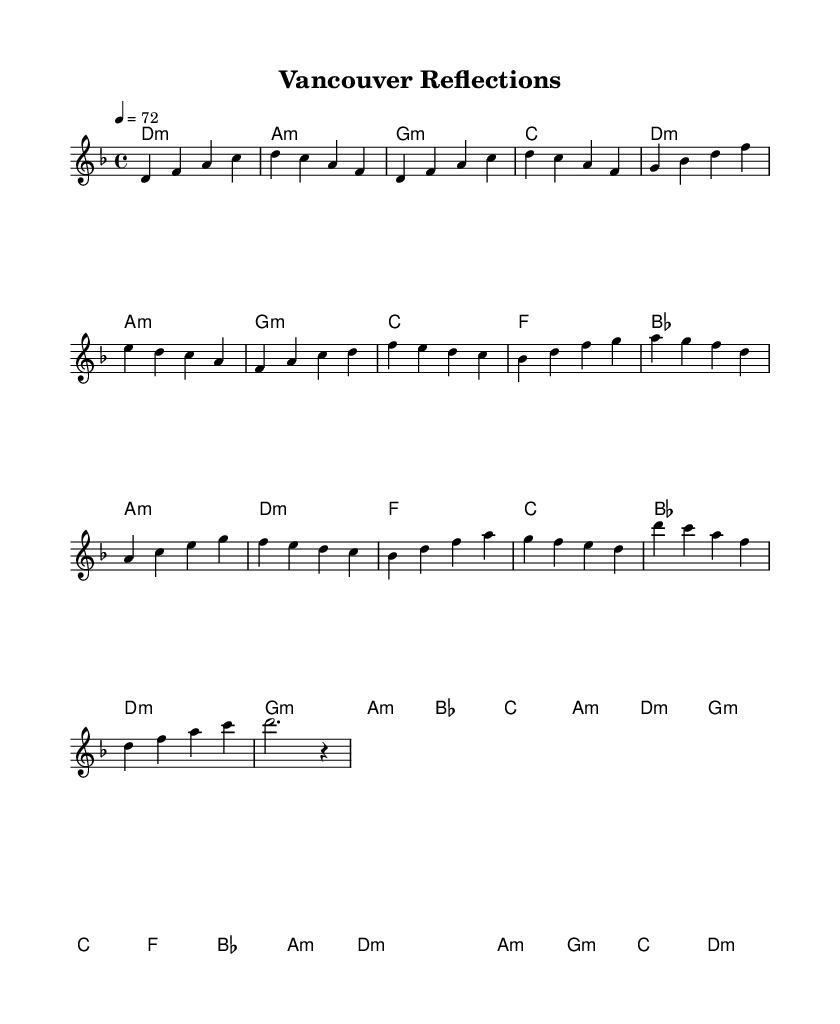What is the key signature of this music? The key signature indicated at the beginning of the staff is D minor, which includes one flat (B flat).
Answer: D minor What is the time signature of this music? The time signature is shown as 4/4, meaning there are four beats in every measure and the quarter note receives one beat.
Answer: 4/4 What is the tempo marking in this sheet music? The tempo marking indicates the music should be played at a speed of quarter note equals 72 beats per minute.
Answer: 72 How many measures are in the chorus section? Counting the segments of the chorus within the score, there are a total of eight measures present in that section.
Answer: 8 What is the last chord in this piece? The last chord before the final rest is D minor, as shown in the harmonies section right before the outro.
Answer: D minor In which section does the melody begin with a D note? The melody starts with a D note in the Intro section as the first note played in the piece.
Answer: Intro What type of musical elements are prominently featured in the piece? The piece prominently features introspective themes and acoustic elements, as suggested by its neo-soul genre characteristics.
Answer: Introspective themes and acoustic elements 